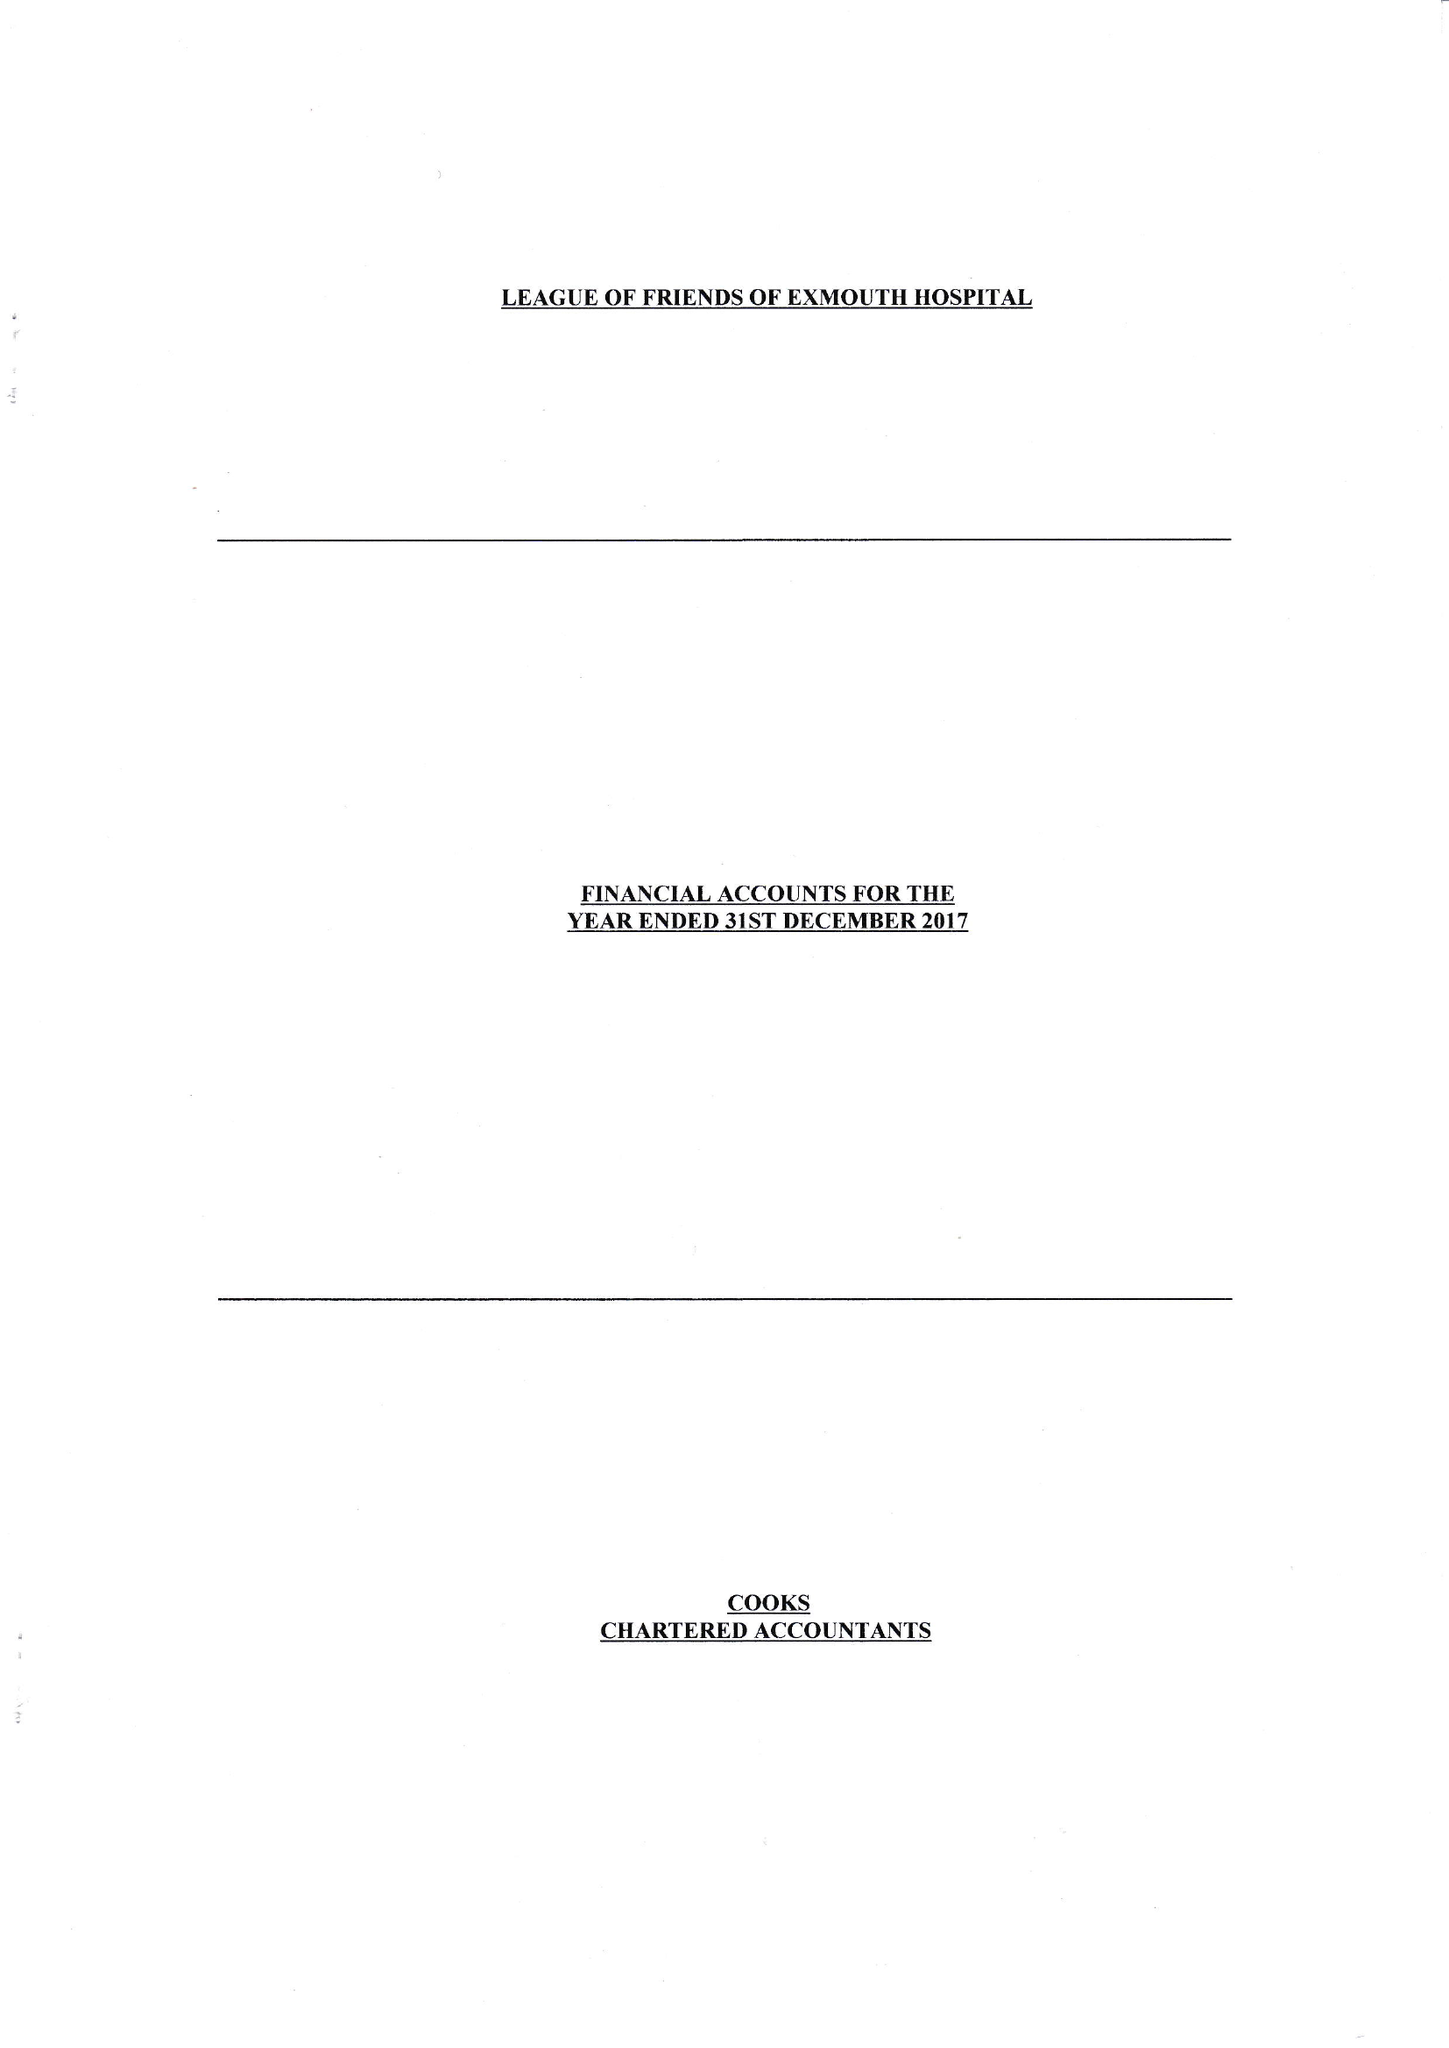What is the value for the income_annually_in_british_pounds?
Answer the question using a single word or phrase. 115664.00 